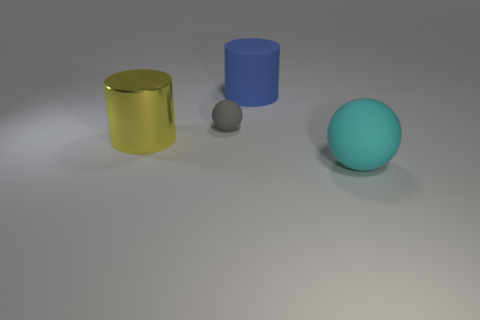How many red things are small spheres or metal things?
Provide a short and direct response. 0. How many things are yellow cubes or things in front of the gray matte sphere?
Provide a succinct answer. 2. There is a yellow object that is left of the gray thing; what material is it?
Offer a terse response. Metal. What shape is the cyan matte thing that is the same size as the yellow cylinder?
Give a very brief answer. Sphere. Is there another large cyan object that has the same shape as the large cyan object?
Your answer should be very brief. No. Is the blue thing made of the same material as the ball that is behind the big cyan rubber thing?
Your answer should be very brief. Yes. The cylinder that is on the left side of the large thing behind the gray object is made of what material?
Your answer should be compact. Metal. Is the number of cylinders right of the big shiny thing greater than the number of big purple objects?
Provide a succinct answer. Yes. Is there a tiny yellow metallic object?
Keep it short and to the point. No. What color is the big thing that is behind the yellow shiny cylinder?
Offer a very short reply. Blue. 